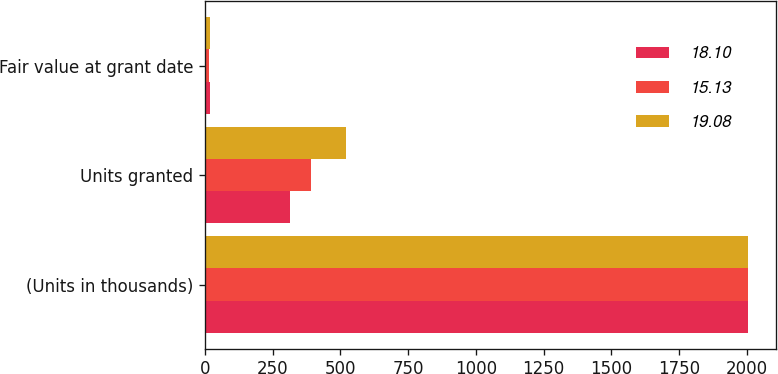Convert chart. <chart><loc_0><loc_0><loc_500><loc_500><stacked_bar_chart><ecel><fcel>(Units in thousands)<fcel>Units granted<fcel>Fair value at grant date<nl><fcel>18.1<fcel>2007<fcel>313<fcel>19.08<nl><fcel>15.13<fcel>2006<fcel>390<fcel>15.13<nl><fcel>19.08<fcel>2005<fcel>519<fcel>18.1<nl></chart> 